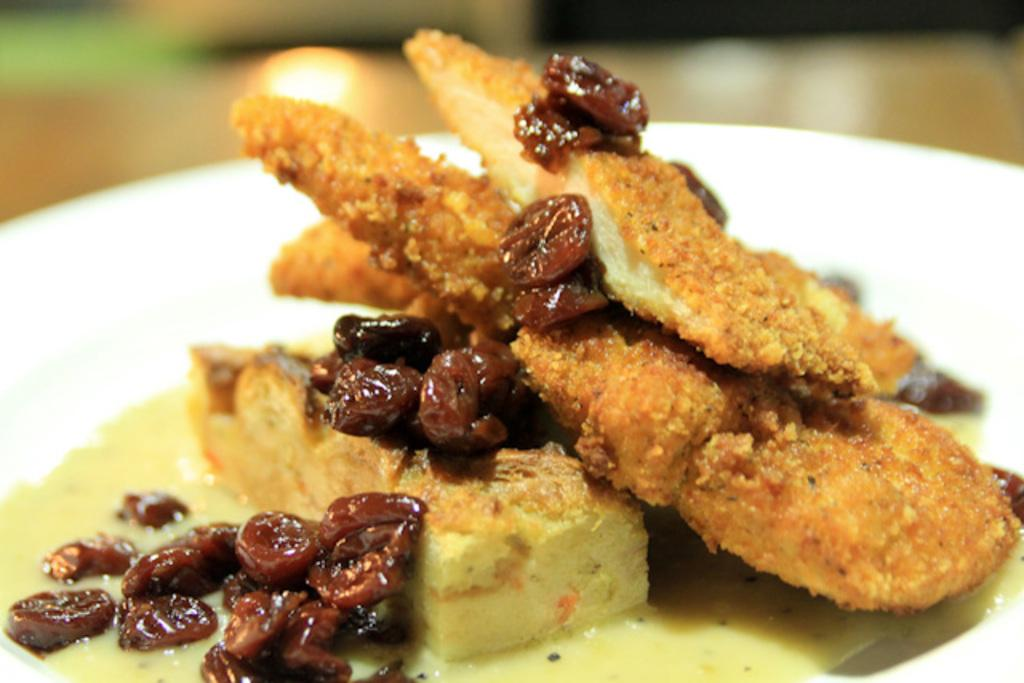What is on the plate in the image? There is a food item on a plate in the image. What color is the plate? The plate is white. Can you describe the background of the image? The background of the image is blurred. What type of basketball is visible in the image? There is no basketball present in the image. What is the condition of the goose in the image? There is no goose present in the image. 